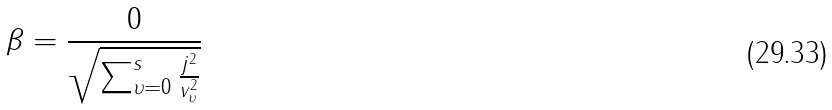<formula> <loc_0><loc_0><loc_500><loc_500>\beta = \frac { 0 } { \sqrt { \sum _ { \upsilon = 0 } ^ { s } \frac { j ^ { 2 } } { v _ { \upsilon } ^ { 2 } } } }</formula> 